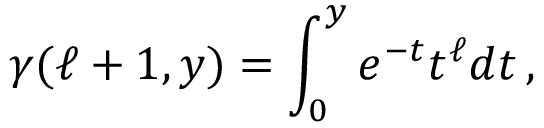Convert formula to latex. <formula><loc_0><loc_0><loc_500><loc_500>\gamma ( \ell + 1 , y ) = \int _ { 0 } ^ { y } e ^ { - t } t ^ { \ell } d t \, ,</formula> 